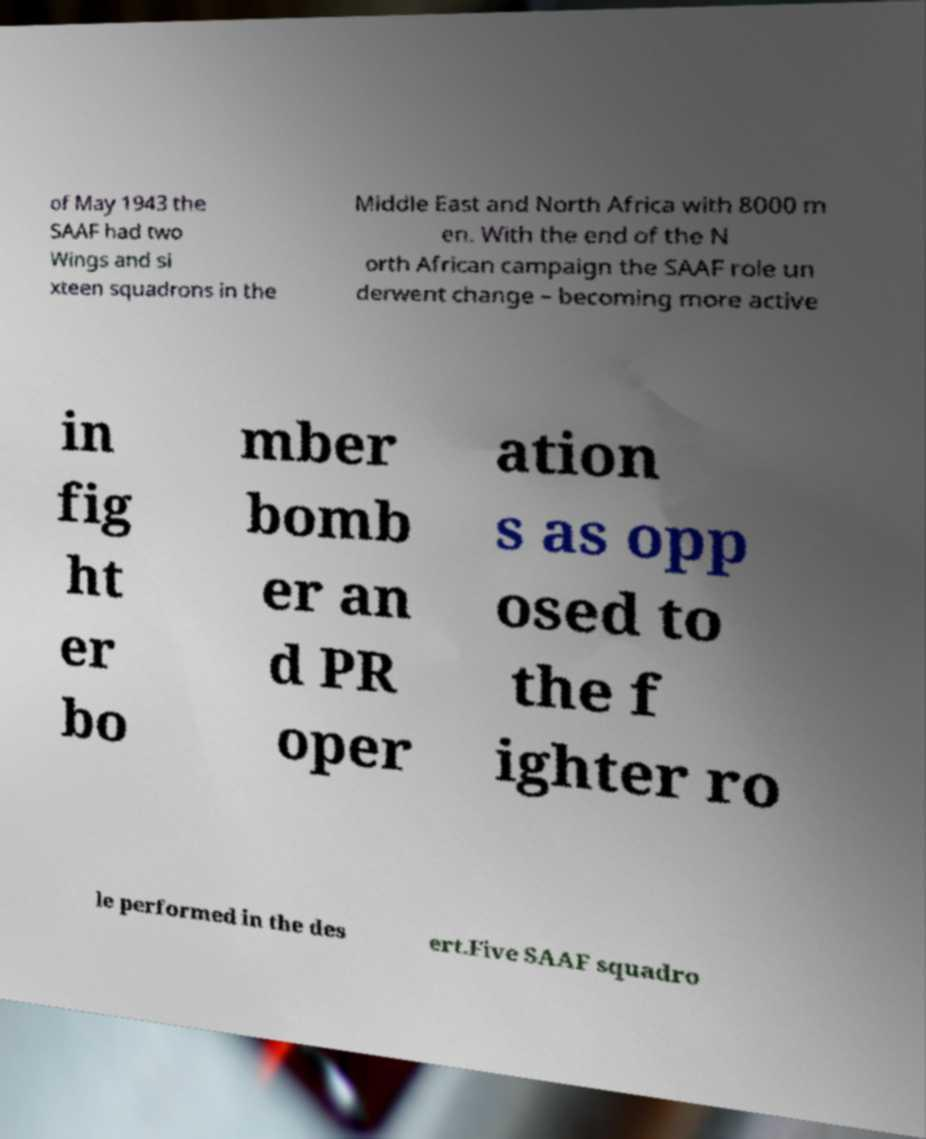What messages or text are displayed in this image? I need them in a readable, typed format. of May 1943 the SAAF had two Wings and si xteen squadrons in the Middle East and North Africa with 8000 m en. With the end of the N orth African campaign the SAAF role un derwent change – becoming more active in fig ht er bo mber bomb er an d PR oper ation s as opp osed to the f ighter ro le performed in the des ert.Five SAAF squadro 